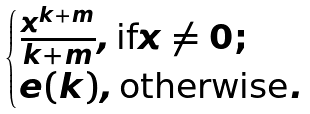<formula> <loc_0><loc_0><loc_500><loc_500>\begin{cases} \frac { x ^ { k + m } } { k + m } , \text {if} x \neq 0 ; \\ e ( k ) , \text {otherwise} . \end{cases}</formula> 